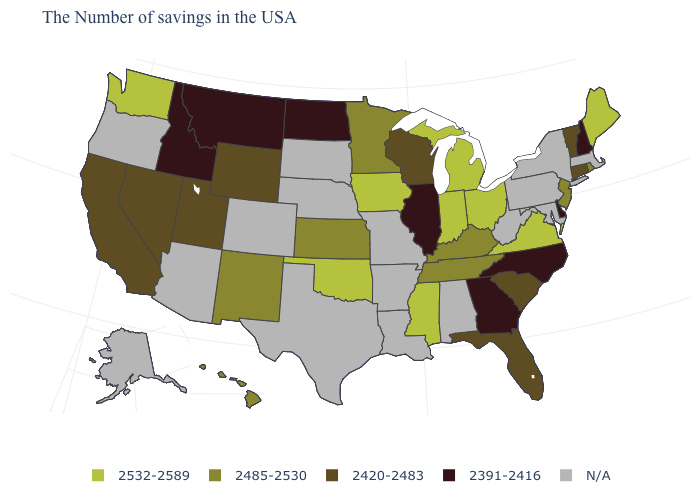Name the states that have a value in the range 2391-2416?
Answer briefly. New Hampshire, Delaware, North Carolina, Georgia, Illinois, North Dakota, Montana, Idaho. Name the states that have a value in the range 2420-2483?
Give a very brief answer. Vermont, Connecticut, South Carolina, Florida, Wisconsin, Wyoming, Utah, Nevada, California. What is the lowest value in the USA?
Keep it brief. 2391-2416. Does the map have missing data?
Short answer required. Yes. Which states hav the highest value in the West?
Be succinct. Washington. Which states have the highest value in the USA?
Be succinct. Maine, Virginia, Ohio, Michigan, Indiana, Mississippi, Iowa, Oklahoma, Washington. Does Hawaii have the lowest value in the West?
Concise answer only. No. What is the value of Vermont?
Short answer required. 2420-2483. Name the states that have a value in the range 2485-2530?
Short answer required. Rhode Island, New Jersey, Kentucky, Tennessee, Minnesota, Kansas, New Mexico, Hawaii. Name the states that have a value in the range 2485-2530?
Short answer required. Rhode Island, New Jersey, Kentucky, Tennessee, Minnesota, Kansas, New Mexico, Hawaii. What is the highest value in the USA?
Answer briefly. 2532-2589. Name the states that have a value in the range N/A?
Write a very short answer. Massachusetts, New York, Maryland, Pennsylvania, West Virginia, Alabama, Louisiana, Missouri, Arkansas, Nebraska, Texas, South Dakota, Colorado, Arizona, Oregon, Alaska. What is the value of Texas?
Quick response, please. N/A. Name the states that have a value in the range 2532-2589?
Concise answer only. Maine, Virginia, Ohio, Michigan, Indiana, Mississippi, Iowa, Oklahoma, Washington. What is the lowest value in the Northeast?
Concise answer only. 2391-2416. 